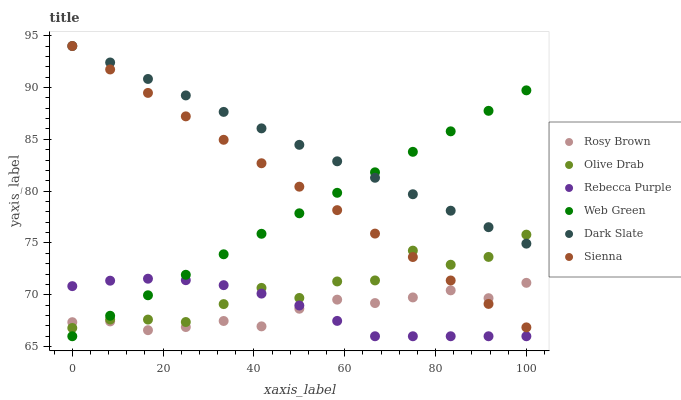Does Rosy Brown have the minimum area under the curve?
Answer yes or no. Yes. Does Dark Slate have the maximum area under the curve?
Answer yes or no. Yes. Does Web Green have the minimum area under the curve?
Answer yes or no. No. Does Web Green have the maximum area under the curve?
Answer yes or no. No. Is Dark Slate the smoothest?
Answer yes or no. Yes. Is Olive Drab the roughest?
Answer yes or no. Yes. Is Web Green the smoothest?
Answer yes or no. No. Is Web Green the roughest?
Answer yes or no. No. Does Web Green have the lowest value?
Answer yes or no. Yes. Does Sienna have the lowest value?
Answer yes or no. No. Does Dark Slate have the highest value?
Answer yes or no. Yes. Does Web Green have the highest value?
Answer yes or no. No. Is Rebecca Purple less than Dark Slate?
Answer yes or no. Yes. Is Dark Slate greater than Rebecca Purple?
Answer yes or no. Yes. Does Rebecca Purple intersect Olive Drab?
Answer yes or no. Yes. Is Rebecca Purple less than Olive Drab?
Answer yes or no. No. Is Rebecca Purple greater than Olive Drab?
Answer yes or no. No. Does Rebecca Purple intersect Dark Slate?
Answer yes or no. No. 